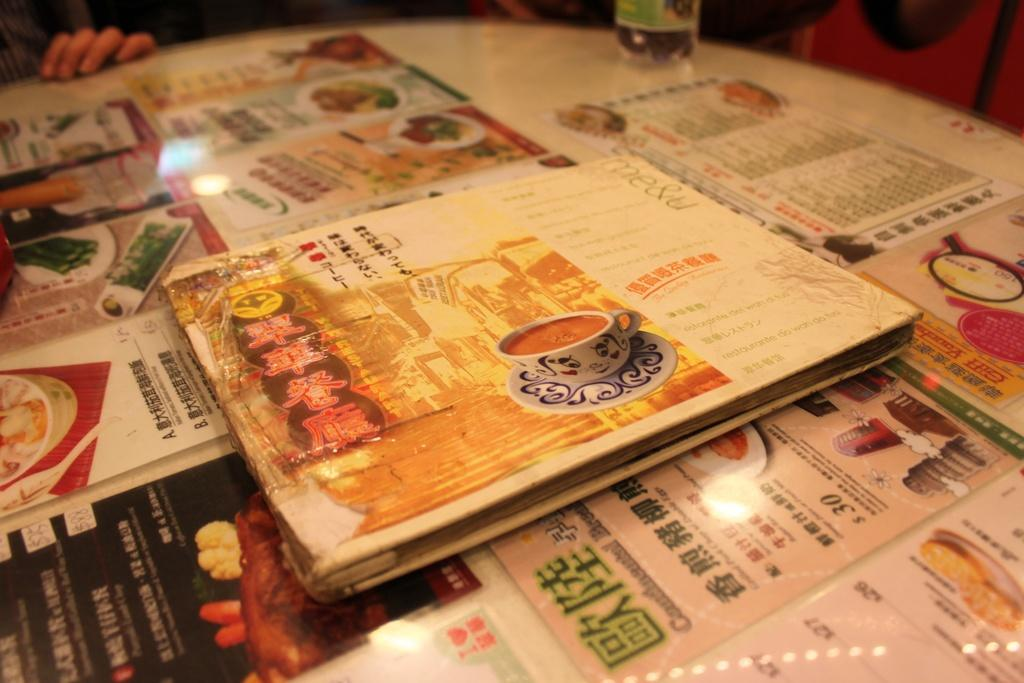What type of object can be seen in the image? There is a book in the image. What else can be seen on the walls in the image? There are posters in the image. What type of paper item is present in the image? There is a menu card in the image. Can you describe the person's hand in the image? A person's hand is visible on a table in the image. What type of box can be seen in the image? There is no box present in the image. How does the fog affect the visibility of the objects in the image? There is no fog present in the image, so it does not affect the visibility of the objects. 